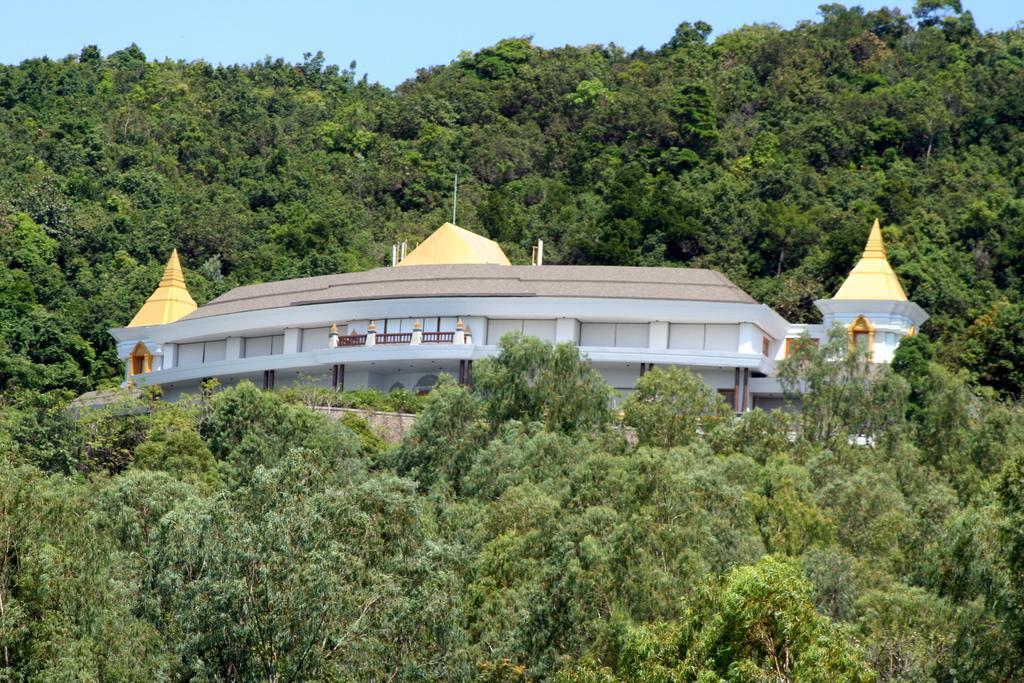In one or two sentences, can you explain what this image depicts? At the center of the image there is a building, around the building there are trees. In the background there is the sky. 